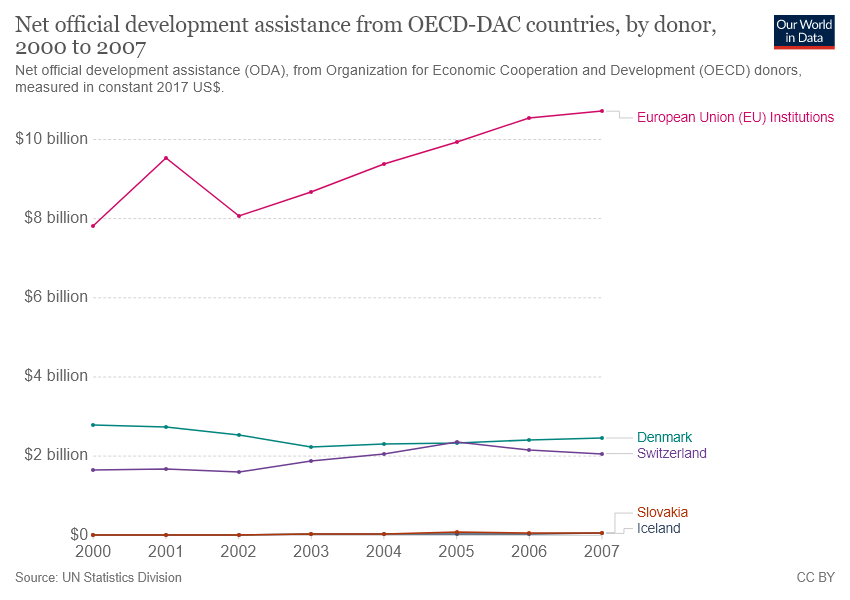Draw attention to some important aspects in this diagram. In 2005, the official development assistance (ODA) from Denmark and Switzerland were the same. The sum of official development assistance (ODA) for Denmark and Switzerland in 2000 was less than $4 billion. 